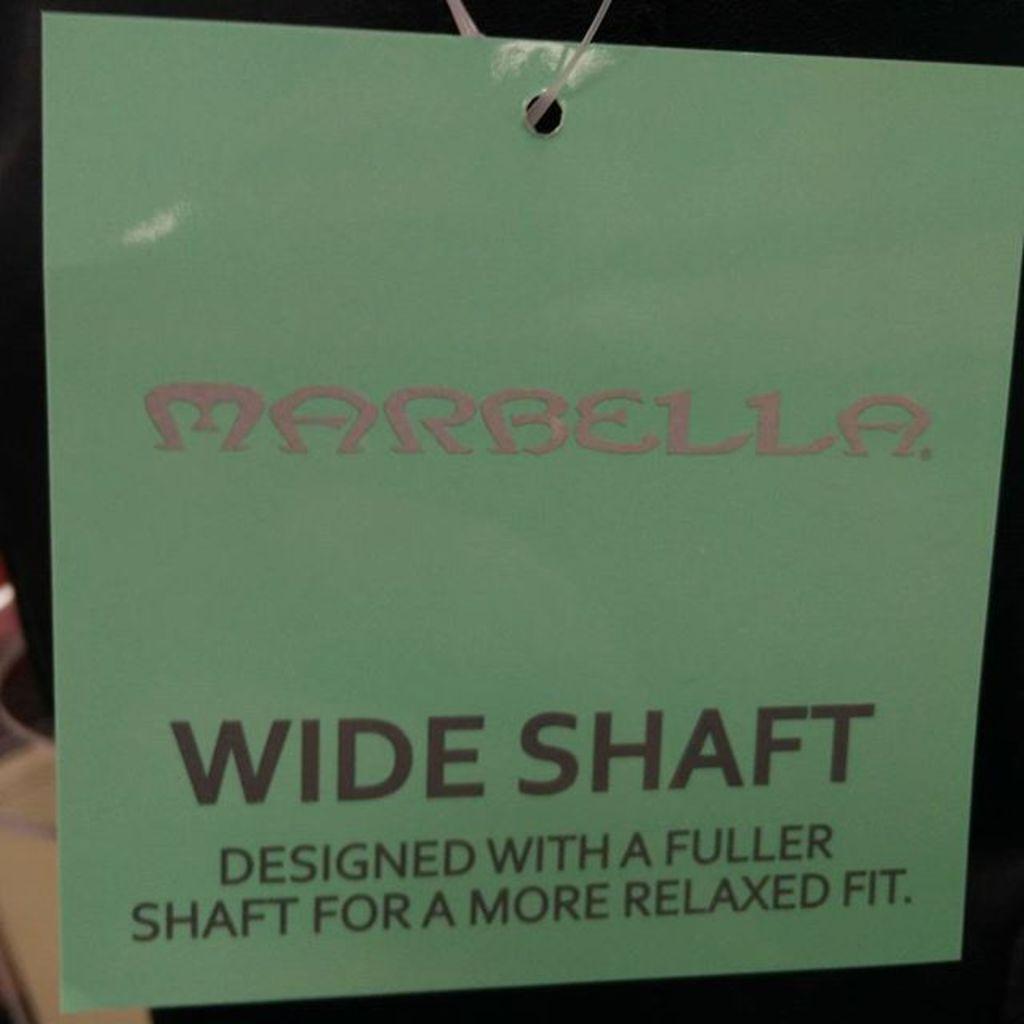What about this product is wide?
Keep it short and to the point. Shaft. What is the brand of the item described?
Provide a succinct answer. Marbella. 